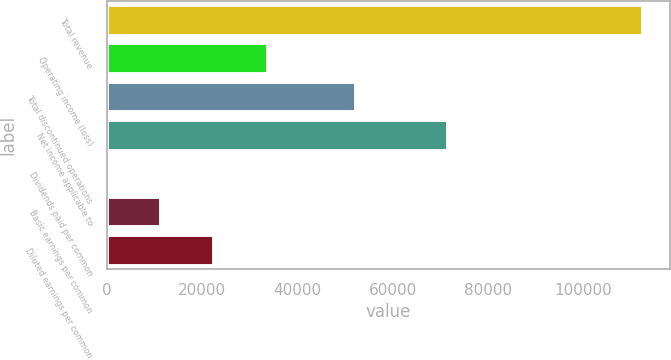Convert chart to OTSL. <chart><loc_0><loc_0><loc_500><loc_500><bar_chart><fcel>Total revenue<fcel>Operating income (loss)<fcel>Total discontinued operations<fcel>Net income applicable to<fcel>Dividends paid per common<fcel>Basic earnings per common<fcel>Diluted earnings per common<nl><fcel>112582<fcel>33774.9<fcel>52340<fcel>71536<fcel>0.42<fcel>11258.6<fcel>22516.7<nl></chart> 